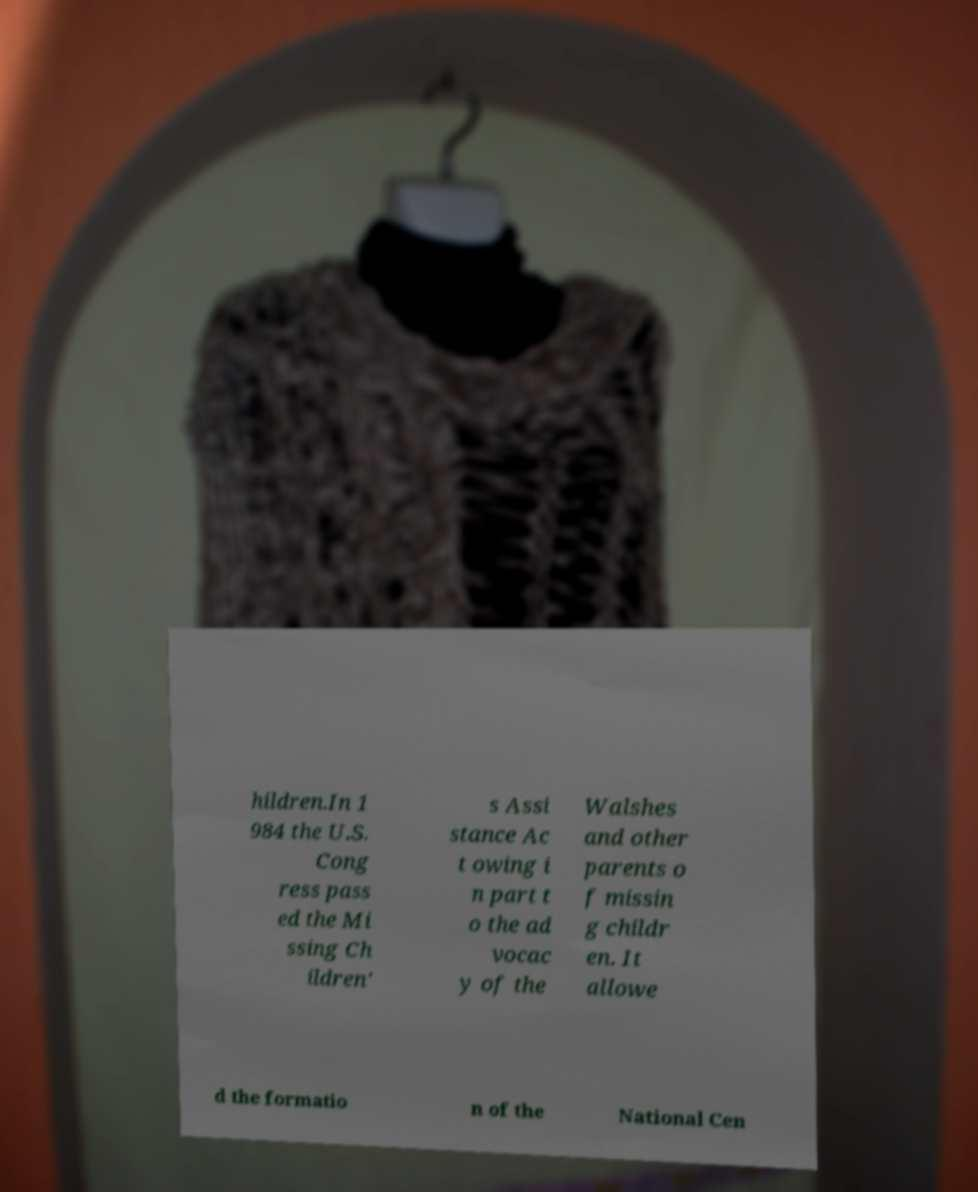Please read and relay the text visible in this image. What does it say? hildren.In 1 984 the U.S. Cong ress pass ed the Mi ssing Ch ildren' s Assi stance Ac t owing i n part t o the ad vocac y of the Walshes and other parents o f missin g childr en. It allowe d the formatio n of the National Cen 